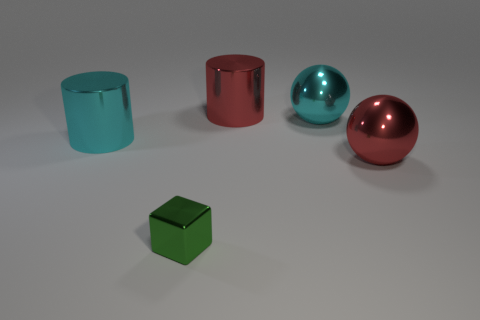Subtract all purple blocks. Subtract all gray cylinders. How many blocks are left? 1 Subtract all cyan spheres. How many brown blocks are left? 0 Add 3 objects. How many tiny purples exist? 0 Subtract all blue matte things. Subtract all tiny green metallic objects. How many objects are left? 4 Add 1 large cylinders. How many large cylinders are left? 3 Add 4 small metallic objects. How many small metallic objects exist? 5 Add 5 green cylinders. How many objects exist? 10 Subtract all cyan cylinders. How many cylinders are left? 1 Subtract 0 green balls. How many objects are left? 5 Subtract all cubes. How many objects are left? 4 